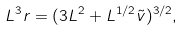Convert formula to latex. <formula><loc_0><loc_0><loc_500><loc_500>L ^ { 3 } r = ( 3 L ^ { 2 } + L ^ { 1 / 2 } \tilde { v } ) ^ { 3 / 2 } ,</formula> 